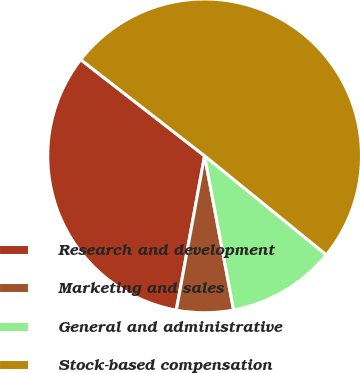Convert chart to OTSL. <chart><loc_0><loc_0><loc_500><loc_500><pie_chart><fcel>Research and development<fcel>Marketing and sales<fcel>General and administrative<fcel>Stock-based compensation<nl><fcel>32.62%<fcel>5.85%<fcel>11.17%<fcel>50.35%<nl></chart> 